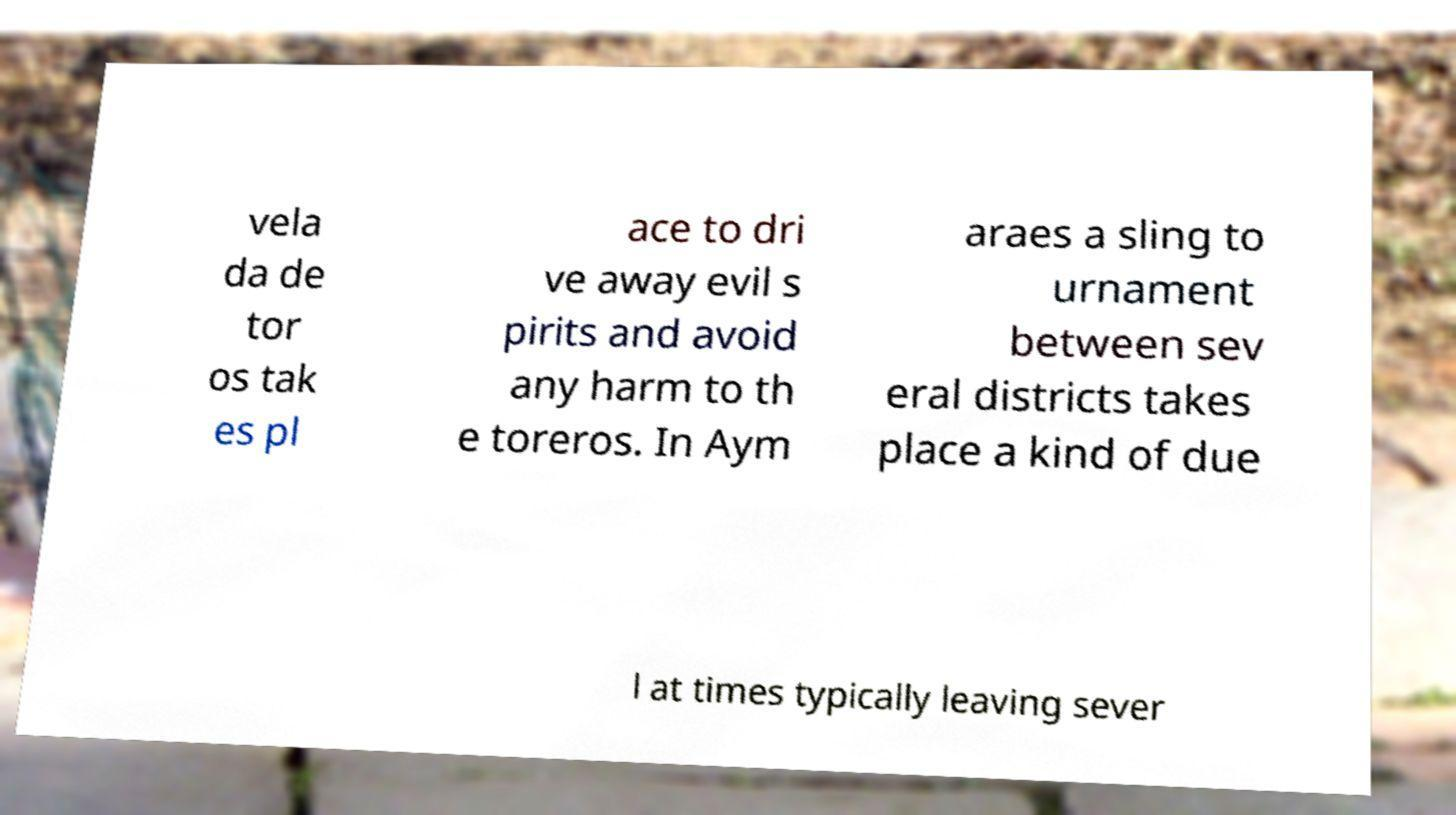For documentation purposes, I need the text within this image transcribed. Could you provide that? vela da de tor os tak es pl ace to dri ve away evil s pirits and avoid any harm to th e toreros. In Aym araes a sling to urnament between sev eral districts takes place a kind of due l at times typically leaving sever 